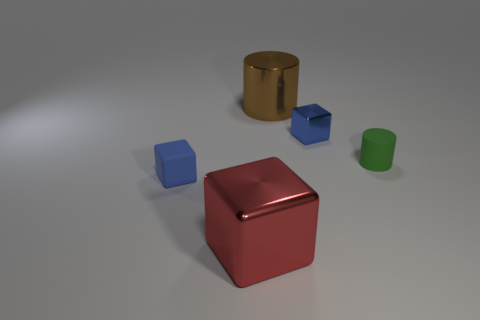Are there any large brown shiny objects that have the same shape as the large red metal thing?
Make the answer very short. No. There is a large metal object that is behind the tiny thing that is left of the blue metal block; what shape is it?
Offer a very short reply. Cylinder. What color is the tiny cylinder in front of the blue shiny cube?
Your answer should be compact. Green. What size is the blue block that is the same material as the big brown object?
Provide a short and direct response. Small. What size is the other metal object that is the same shape as the green object?
Provide a short and direct response. Large. Are any big gray shiny objects visible?
Offer a very short reply. No. How many things are either tiny blue blocks on the left side of the large block or green rubber balls?
Keep it short and to the point. 1. What is the material of the cylinder that is the same size as the red metallic object?
Ensure brevity in your answer.  Metal. The rubber thing to the right of the tiny blue cube in front of the tiny blue shiny block is what color?
Ensure brevity in your answer.  Green. There is a matte cube; how many small blue things are on the right side of it?
Give a very brief answer. 1. 